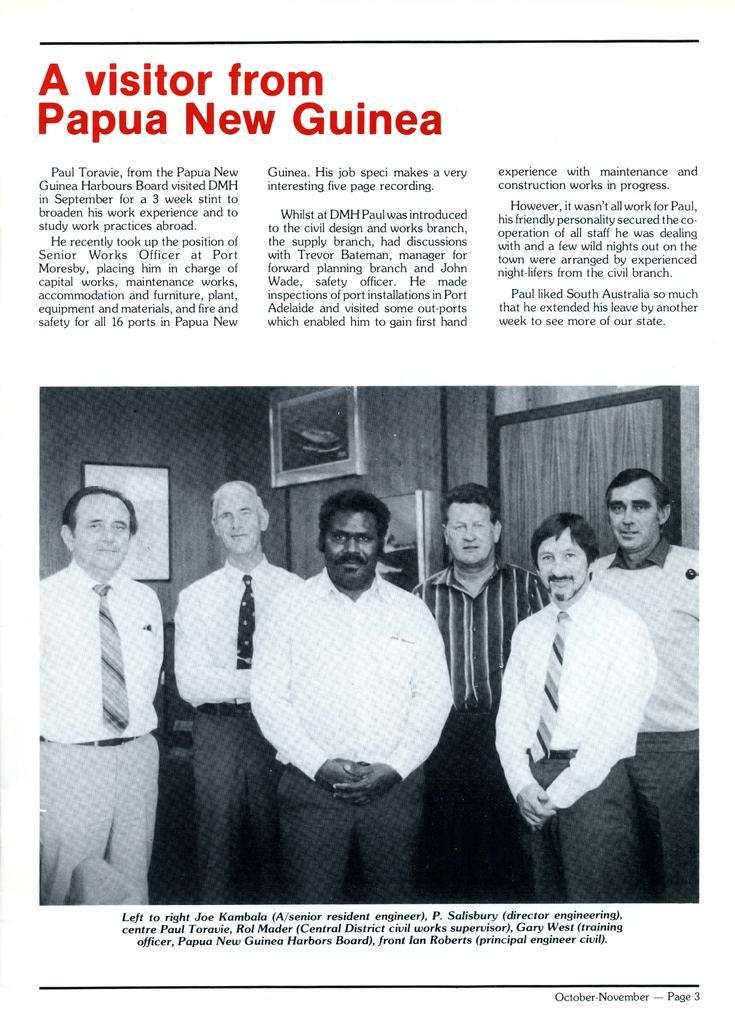Please provide a concise description of this image. In this image, we can see a magazine paper. Here we can see some text. Here there is an image. In that image, group of people are standing. Background there is a wall, some objects, curtain. 